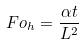Convert formula to latex. <formula><loc_0><loc_0><loc_500><loc_500>F o _ { h } = \frac { \alpha t } { L ^ { 2 } }</formula> 